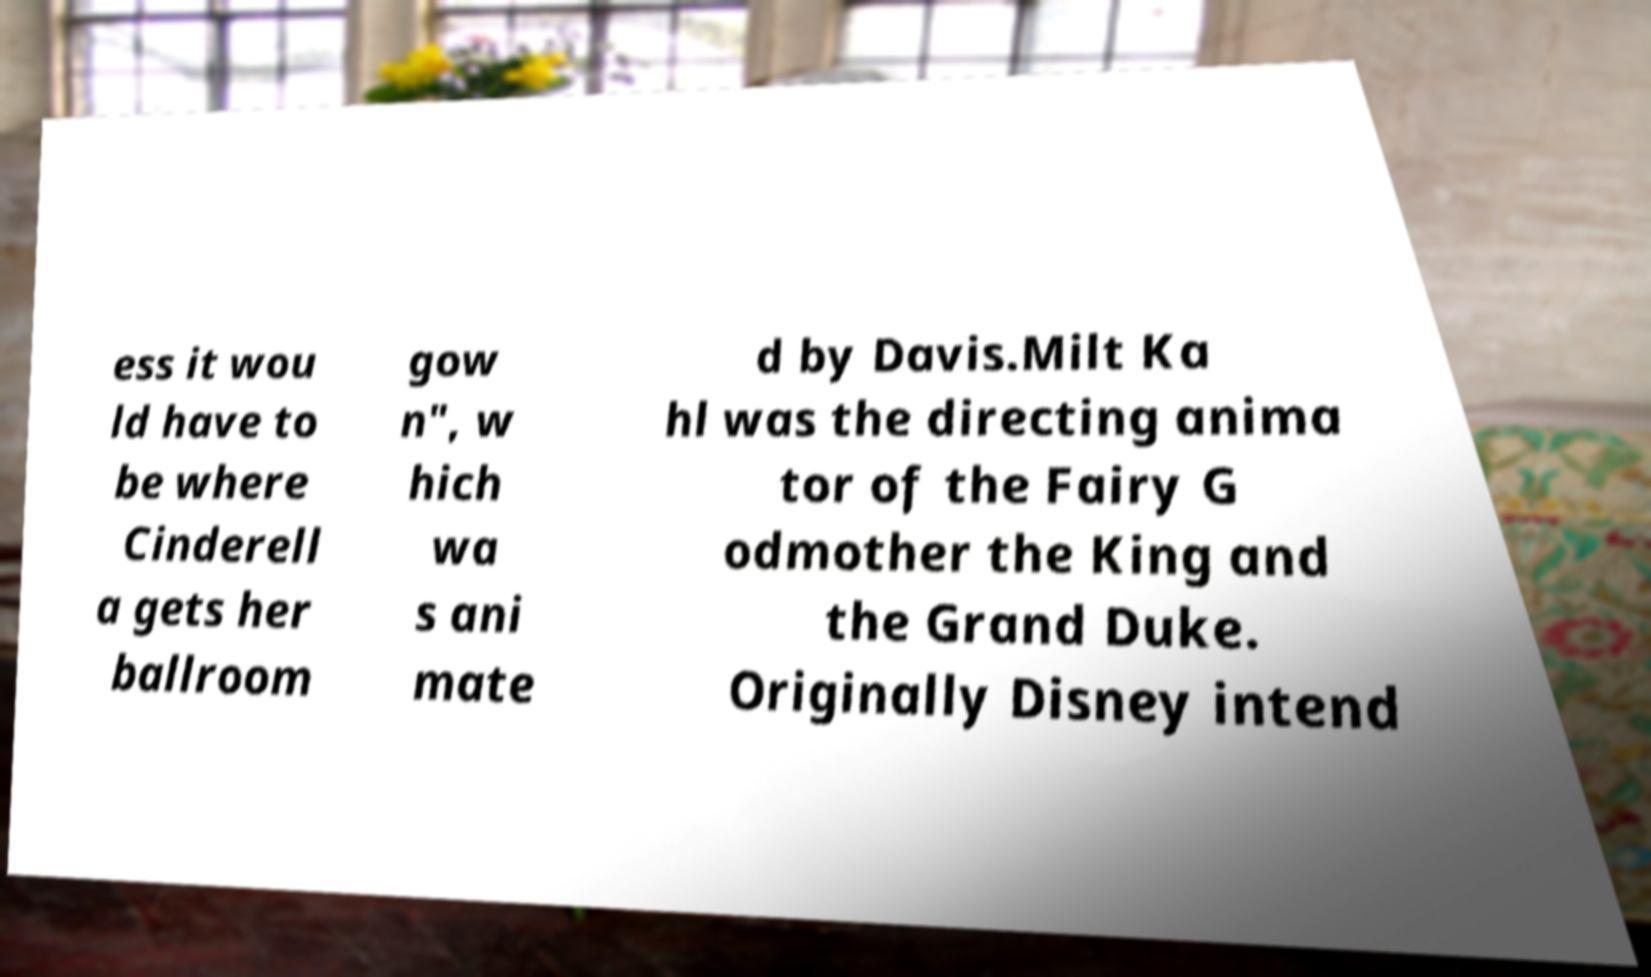Can you accurately transcribe the text from the provided image for me? ess it wou ld have to be where Cinderell a gets her ballroom gow n", w hich wa s ani mate d by Davis.Milt Ka hl was the directing anima tor of the Fairy G odmother the King and the Grand Duke. Originally Disney intend 